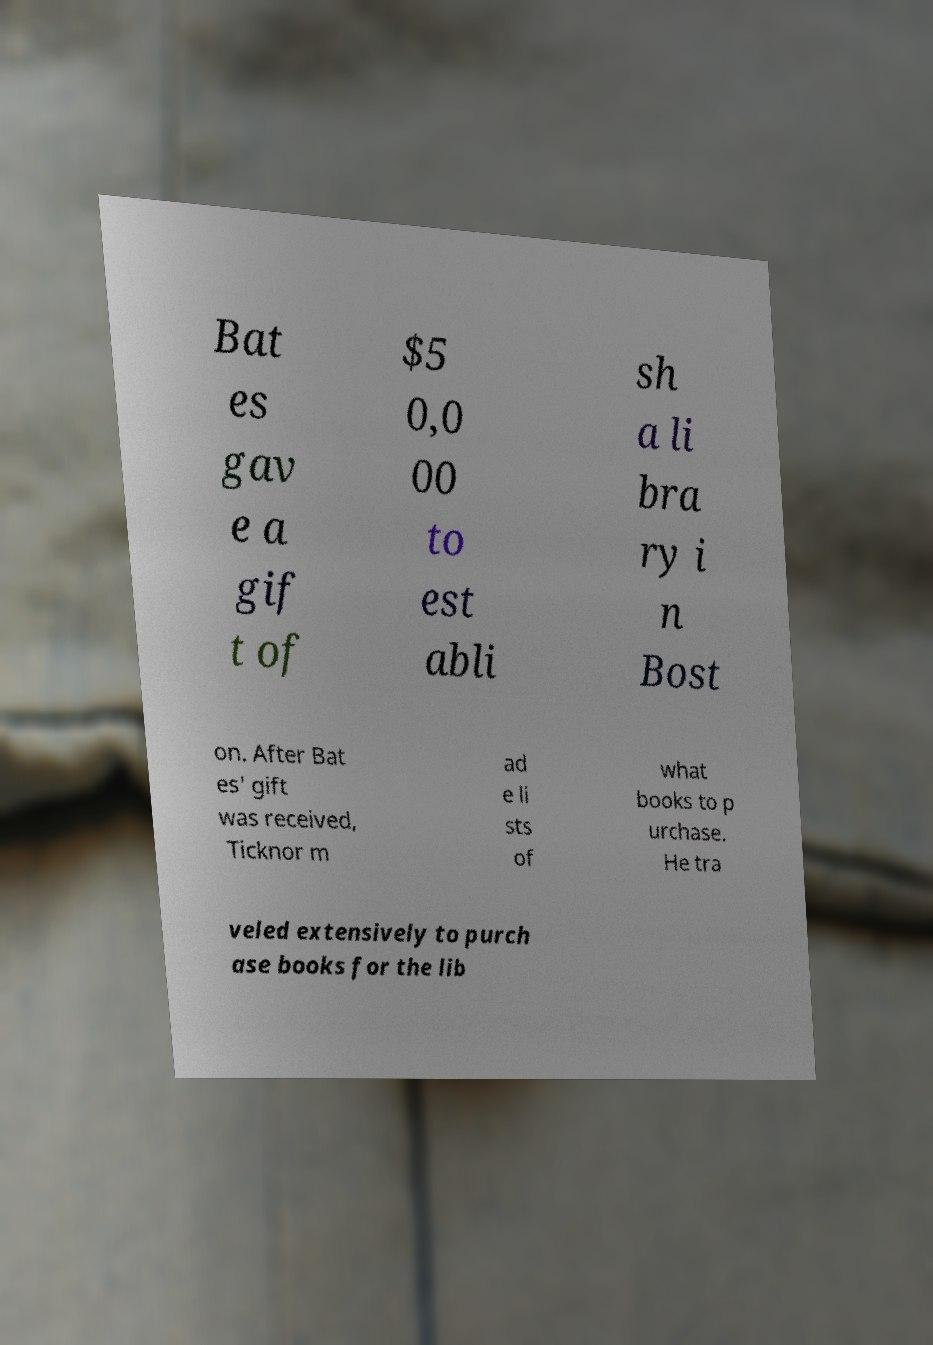For documentation purposes, I need the text within this image transcribed. Could you provide that? Bat es gav e a gif t of $5 0,0 00 to est abli sh a li bra ry i n Bost on. After Bat es' gift was received, Ticknor m ad e li sts of what books to p urchase. He tra veled extensively to purch ase books for the lib 